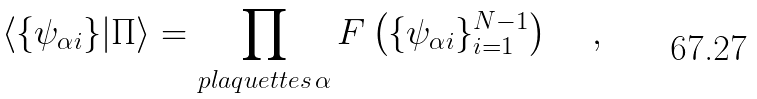<formula> <loc_0><loc_0><loc_500><loc_500>\langle \{ \psi _ { \alpha i } \} | \Pi \rangle = \prod _ { p l a q u e t t e s \, \alpha } F \left ( \{ \psi _ { \alpha i } \} _ { i = 1 } ^ { N - 1 } \right ) \quad \, ,</formula> 